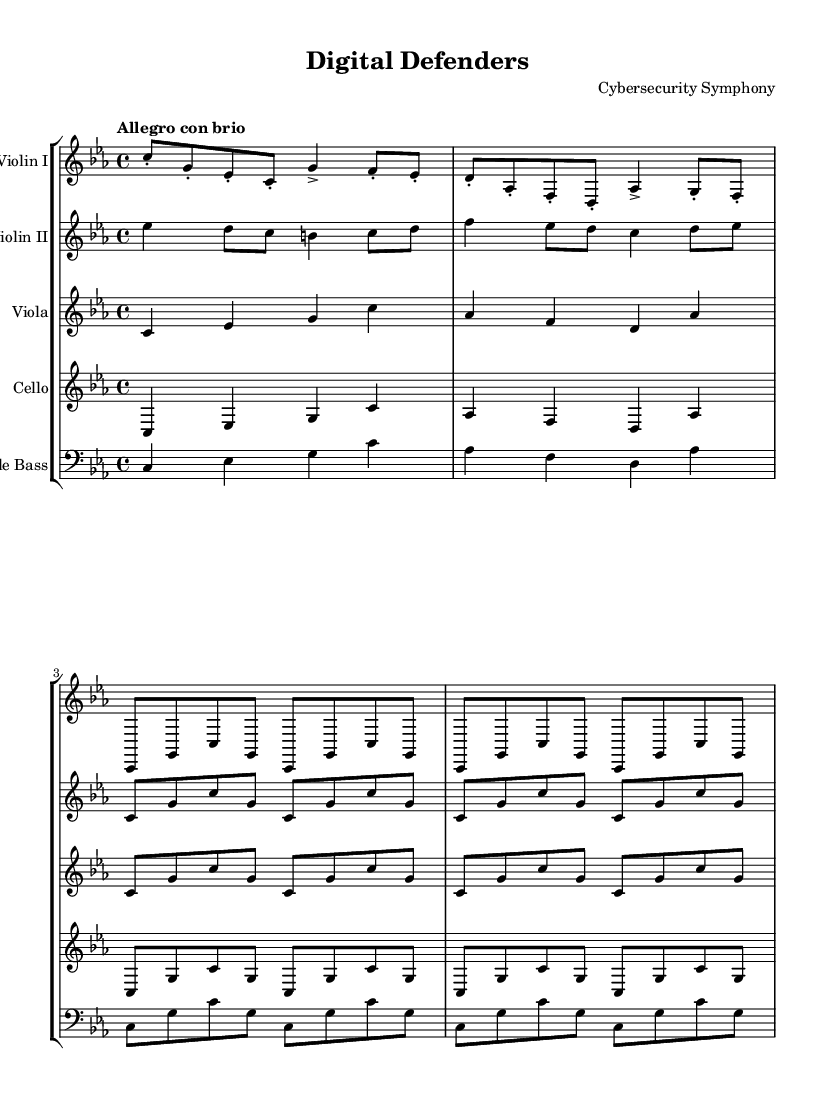What is the key signature of this music? The key signature is C minor, which features three flats: B flat, E flat, and A flat.
Answer: C minor What is the time signature of this music? The time signature is indicated by the "4/4" at the beginning, meaning there are four beats in each measure and a quarter note gets one beat.
Answer: 4/4 What is the tempo marking for this piece? The tempo marking is "Allegro con brio," which implies a lively and spirited pace, generally around 120-168 beats per minute.
Answer: Allegro con brio How many times does the main theme repeat in the violin sections? The main theme, notated with a sequence, is repeated two times in both the Violin I and Violin II parts as indicated by "\repeat unfold 2."
Answer: 2 What instruments are included in this symphony? The symphony features strings, including Violin I, Violin II, Viola, Cello, and Double Bass, as listed in the score structure.
Answer: Violin I, Violin II, Viola, Cello, Double Bass Which instrument plays the first note of the piece? The first note of the piece is played by the Violin I, starting on C.
Answer: Violin I What harmony type is primarily used in this symphony? The harmony type is primarily homophonic, as one main melodic line is supported by the accompaniment in the string sections.
Answer: Homophonic 